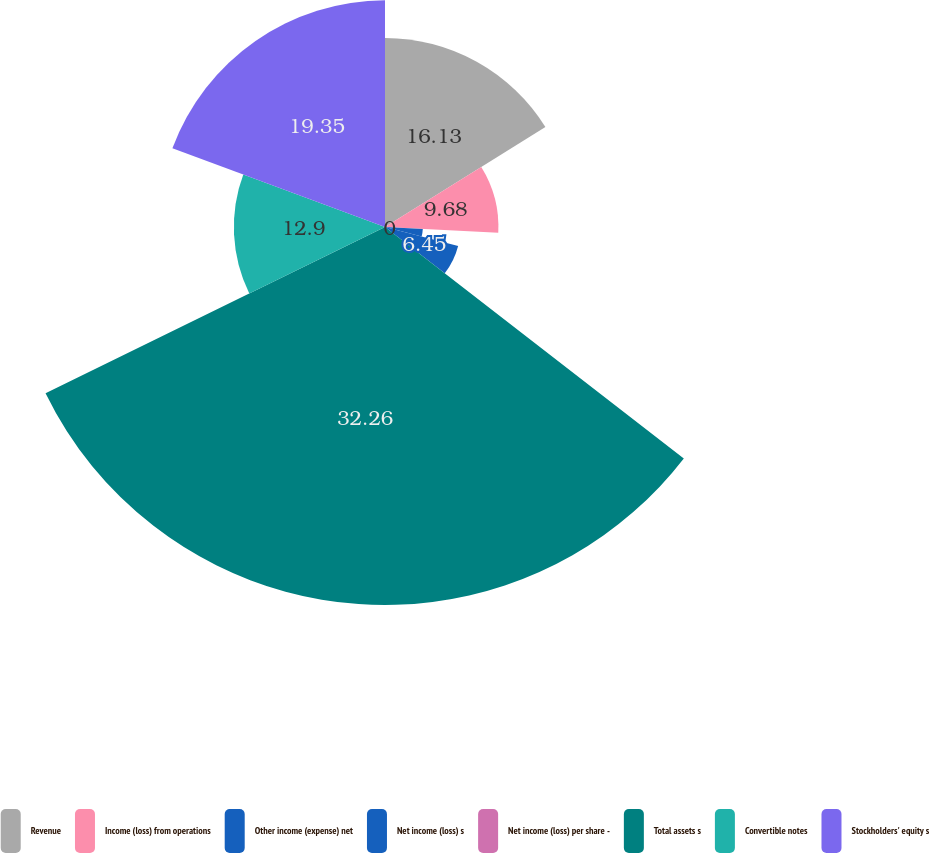Convert chart to OTSL. <chart><loc_0><loc_0><loc_500><loc_500><pie_chart><fcel>Revenue<fcel>Income (loss) from operations<fcel>Other income (expense) net<fcel>Net income (loss) s<fcel>Net income (loss) per share -<fcel>Total assets s<fcel>Convertible notes<fcel>Stockholders' equity s<nl><fcel>16.13%<fcel>9.68%<fcel>3.23%<fcel>6.45%<fcel>0.0%<fcel>32.26%<fcel>12.9%<fcel>19.35%<nl></chart> 